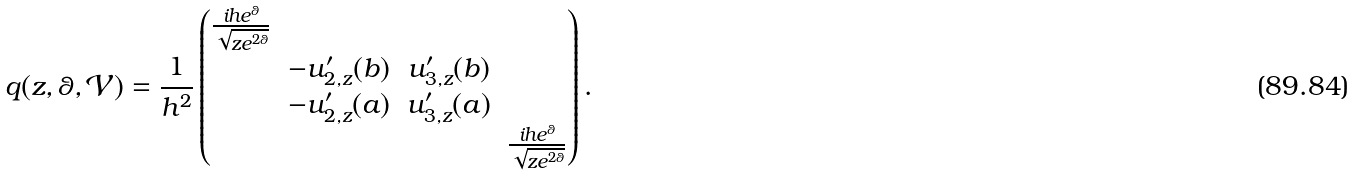Convert formula to latex. <formula><loc_0><loc_0><loc_500><loc_500>q ( z , \theta , \mathcal { V } ) = \frac { 1 } { h ^ { 2 } } \begin{pmatrix} \frac { i h e ^ { \theta } } { \sqrt { z e ^ { 2 \theta } } } & & & \\ & - u _ { 2 , z } ^ { \prime } ( b ) & u _ { 3 , z } ^ { \prime } ( b ) & \\ & - u _ { 2 , z } ^ { \prime } ( a ) & u _ { 3 , z } ^ { \prime } ( a ) & \\ & & & \frac { i h e ^ { \theta } } { \sqrt { z e ^ { 2 \theta } } } \end{pmatrix} .</formula> 